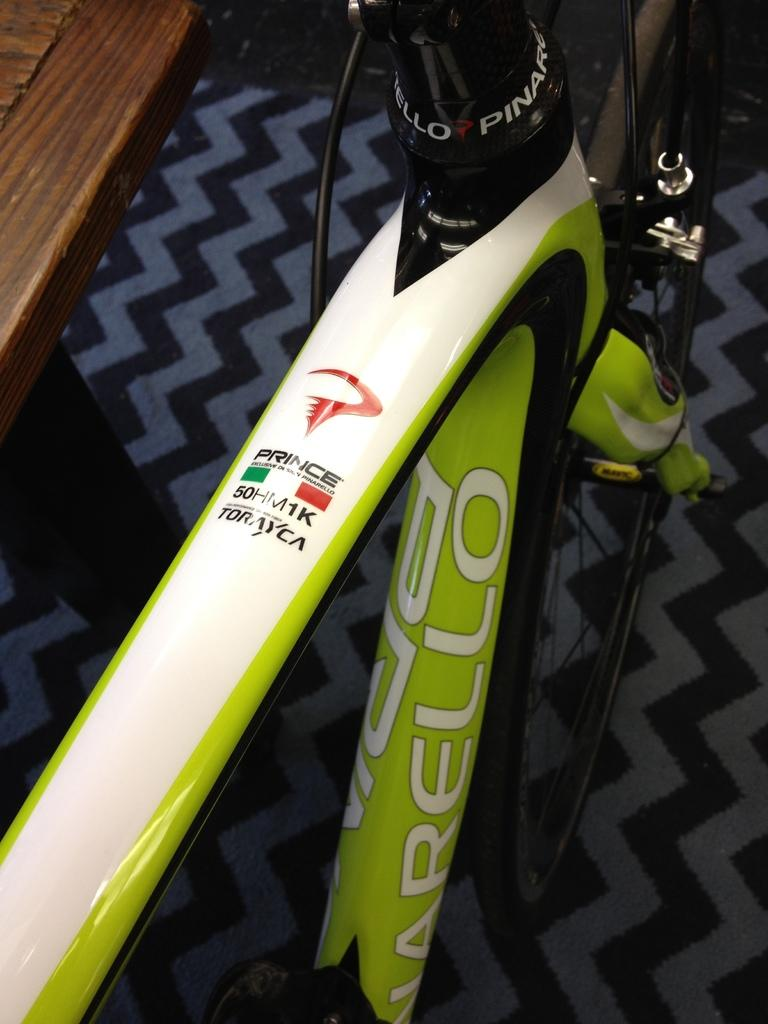What object is on the floor in the image? There is a bicycle on the floor in the image. Can you describe anything in the background of the image? There is a wooden object in the background of the image. How many snails can be seen crawling on the bicycle in the image? There are no snails visible on the bicycle in the image. What part of the body is associated with the wooden object in the background? The wooden object in the background is not associated with any specific part of the body. 